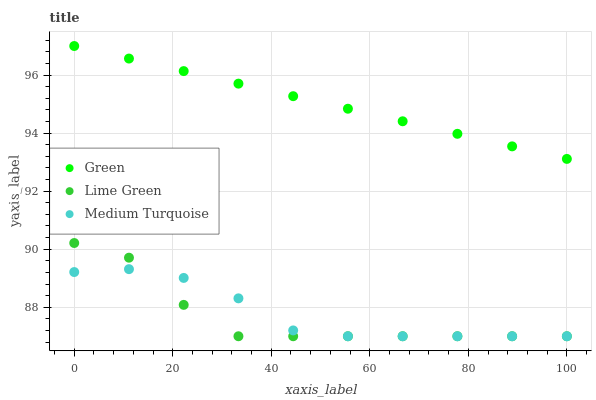Does Lime Green have the minimum area under the curve?
Answer yes or no. Yes. Does Green have the maximum area under the curve?
Answer yes or no. Yes. Does Medium Turquoise have the minimum area under the curve?
Answer yes or no. No. Does Medium Turquoise have the maximum area under the curve?
Answer yes or no. No. Is Green the smoothest?
Answer yes or no. Yes. Is Lime Green the roughest?
Answer yes or no. Yes. Is Medium Turquoise the smoothest?
Answer yes or no. No. Is Medium Turquoise the roughest?
Answer yes or no. No. Does Lime Green have the lowest value?
Answer yes or no. Yes. Does Green have the lowest value?
Answer yes or no. No. Does Green have the highest value?
Answer yes or no. Yes. Does Medium Turquoise have the highest value?
Answer yes or no. No. Is Medium Turquoise less than Green?
Answer yes or no. Yes. Is Green greater than Medium Turquoise?
Answer yes or no. Yes. Does Medium Turquoise intersect Lime Green?
Answer yes or no. Yes. Is Medium Turquoise less than Lime Green?
Answer yes or no. No. Is Medium Turquoise greater than Lime Green?
Answer yes or no. No. Does Medium Turquoise intersect Green?
Answer yes or no. No. 